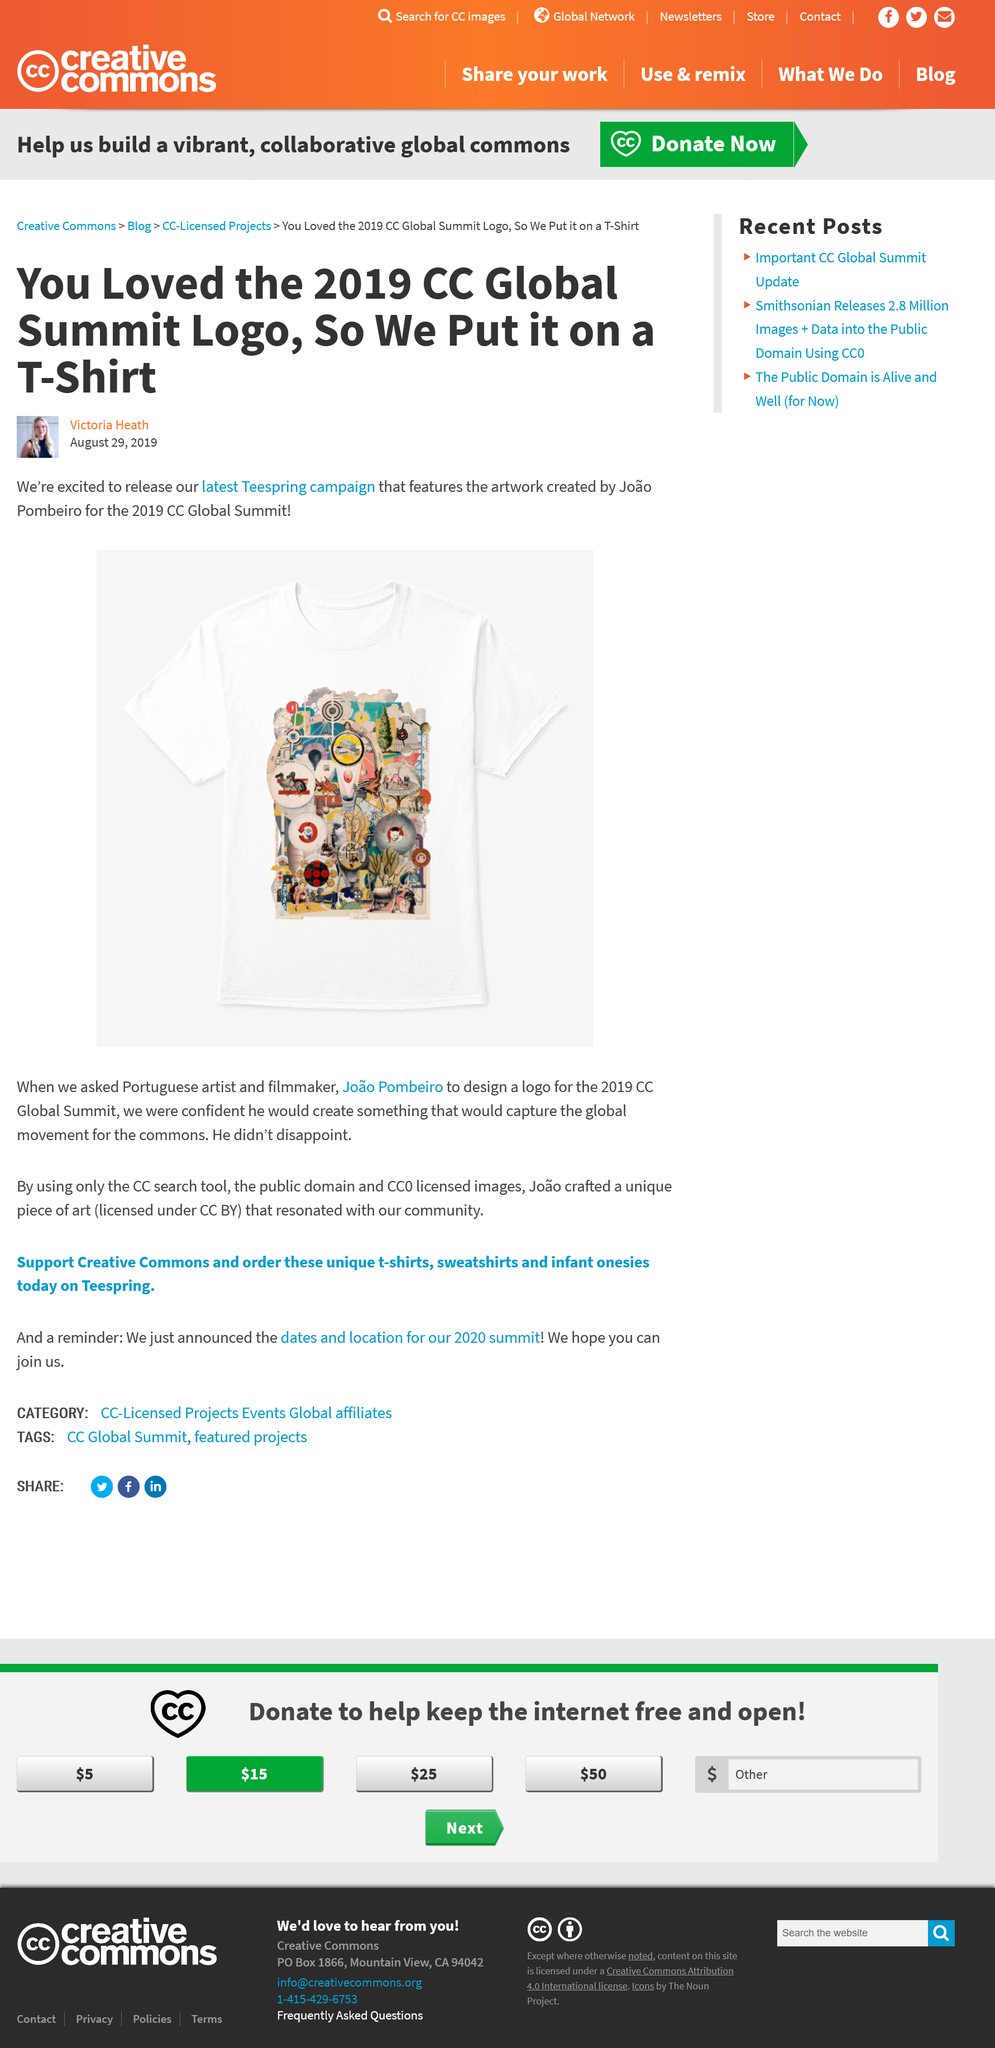Highlight a few significant elements in this photo. The article was written by Victoria Heath. The logo designed for the T-Shirt was created by Joāo Pombeiro. This article was written on August 29, 2019, as evidenced by the date stamp on the document. 